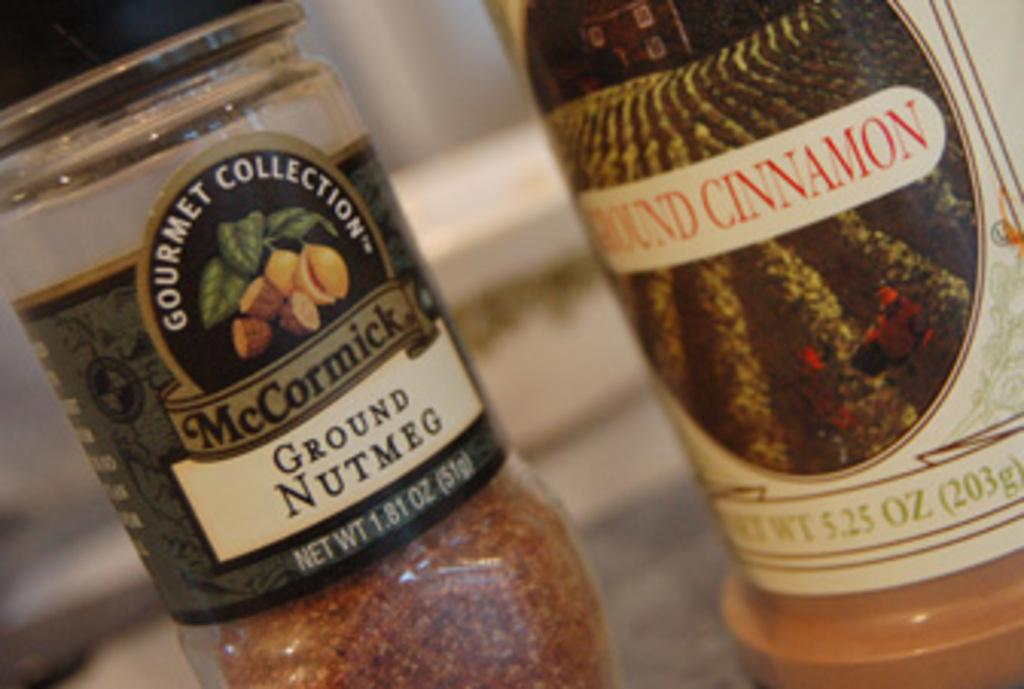<image>
Give a short and clear explanation of the subsequent image. A jar of McCormick nutmeg is next to ground cinnamon. 